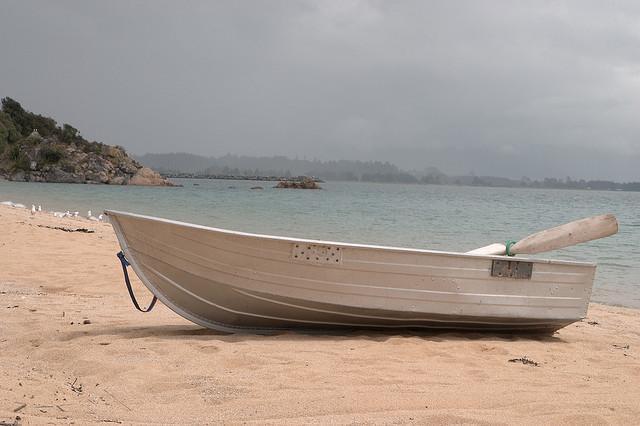How many boats are pictured?
Give a very brief answer. 1. 